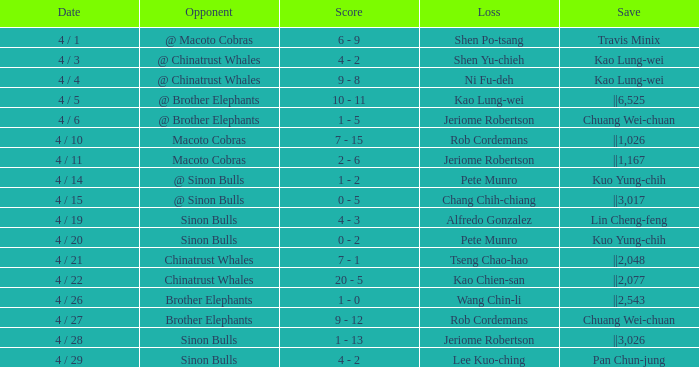Who received the save during the game against the sinon bulls when jeriome robertson experienced a defeat? ||3,026. 